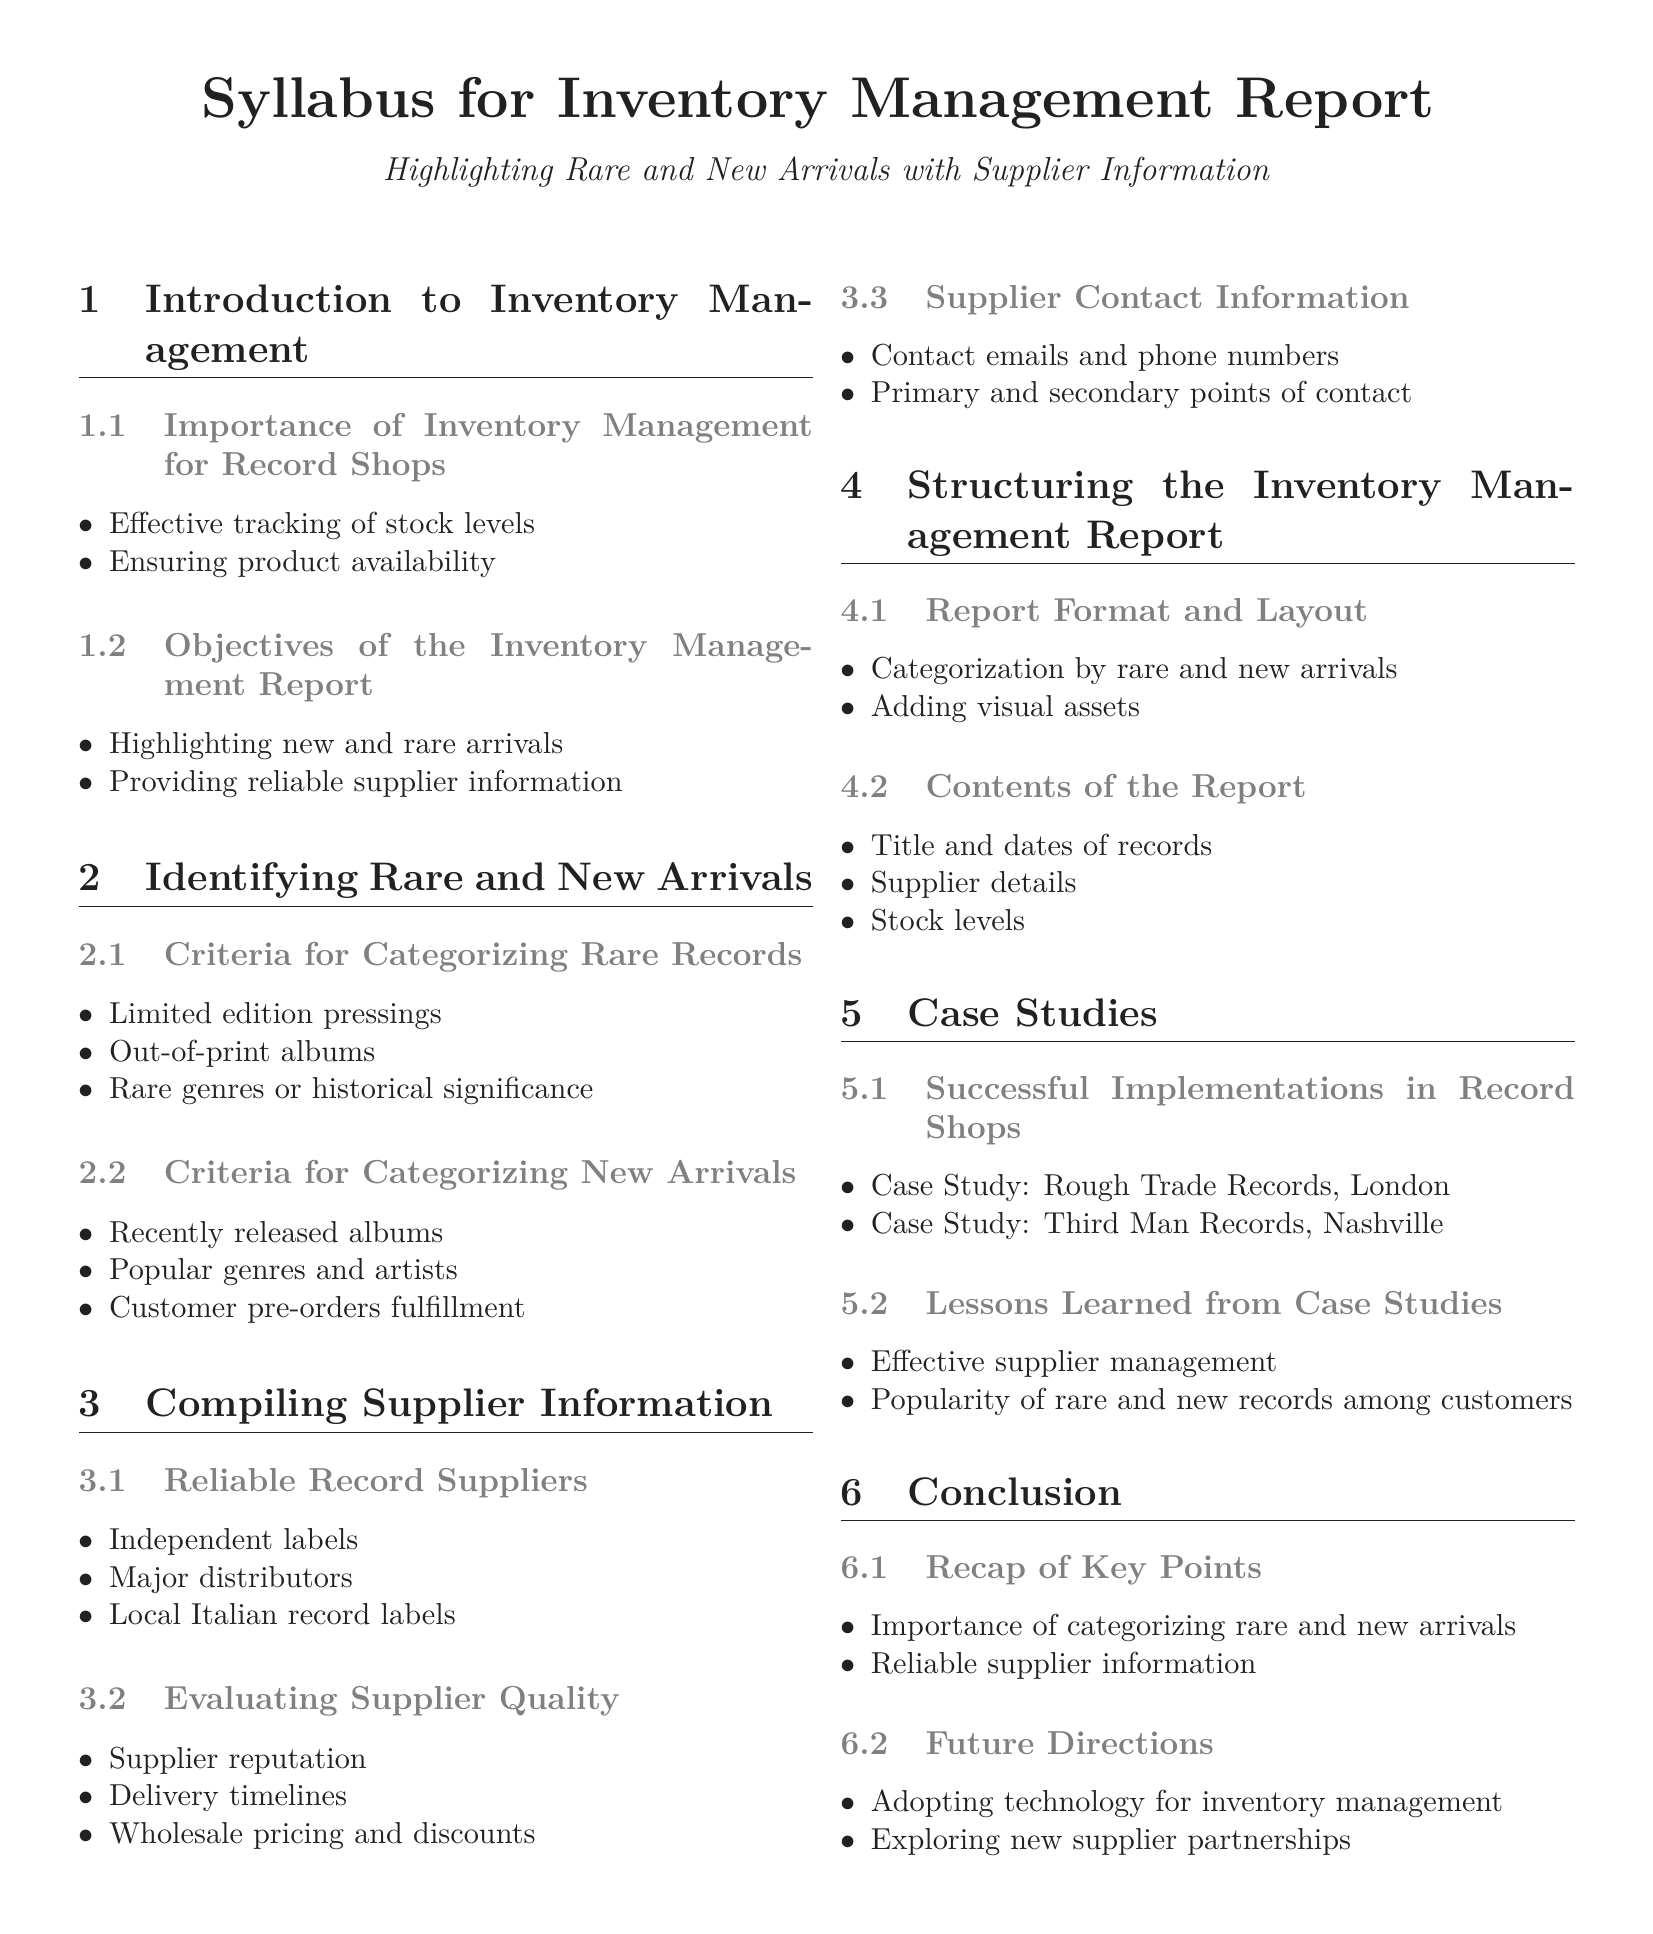what is the title of the syllabus? The title of the syllabus is stated at the beginning of the document.
Answer: Syllabus for Inventory Management Report what are the two main objectives of the Inventory Management Report? The objectives are listed under a subsection and can be clearly identified.
Answer: Highlighting new and rare arrivals, providing reliable supplier information what is one criterion for categorizing rare records? The criteria for rare records are listed under a subsection in the document.
Answer: Limited edition pressings name a type of reliable record supplier mentioned in the syllabus. The types of suppliers are enumerated, and can be directly quoted.
Answer: Independent labels how many case studies are presented in the document? The number of case studies is mentioned in a specific subsection.
Answer: Two what is a lesson learned from the case studies? The lessons learned are also listed in a subsection and can be directly referenced.
Answer: Effective supplier management what is the suggested future direction for inventory management? The future directions are outlined at the end of the document, indicating aspirations for the business.
Answer: Adopting technology for inventory management how should the inventory management report be structured? The document provides specific guidance on the report layout and organization.
Answer: Categorization by rare and new arrivals 